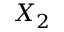<formula> <loc_0><loc_0><loc_500><loc_500>X _ { 2 }</formula> 